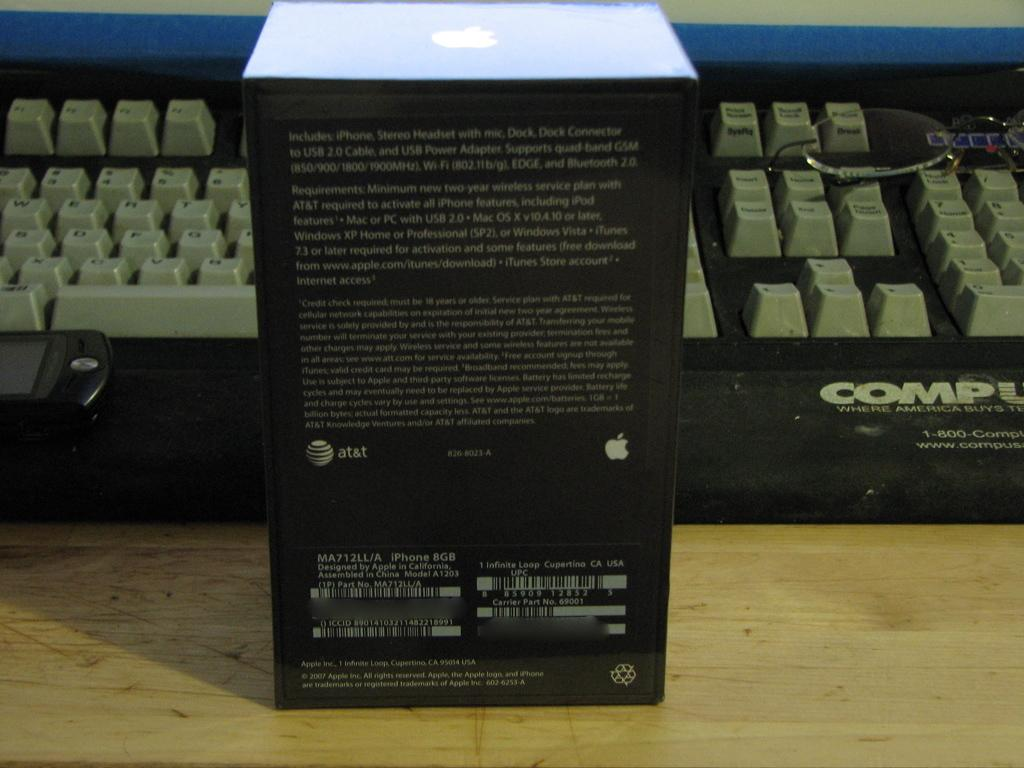Provide a one-sentence caption for the provided image. A black box with an Apple product utilzing AT&T services in front of a keyboard. 